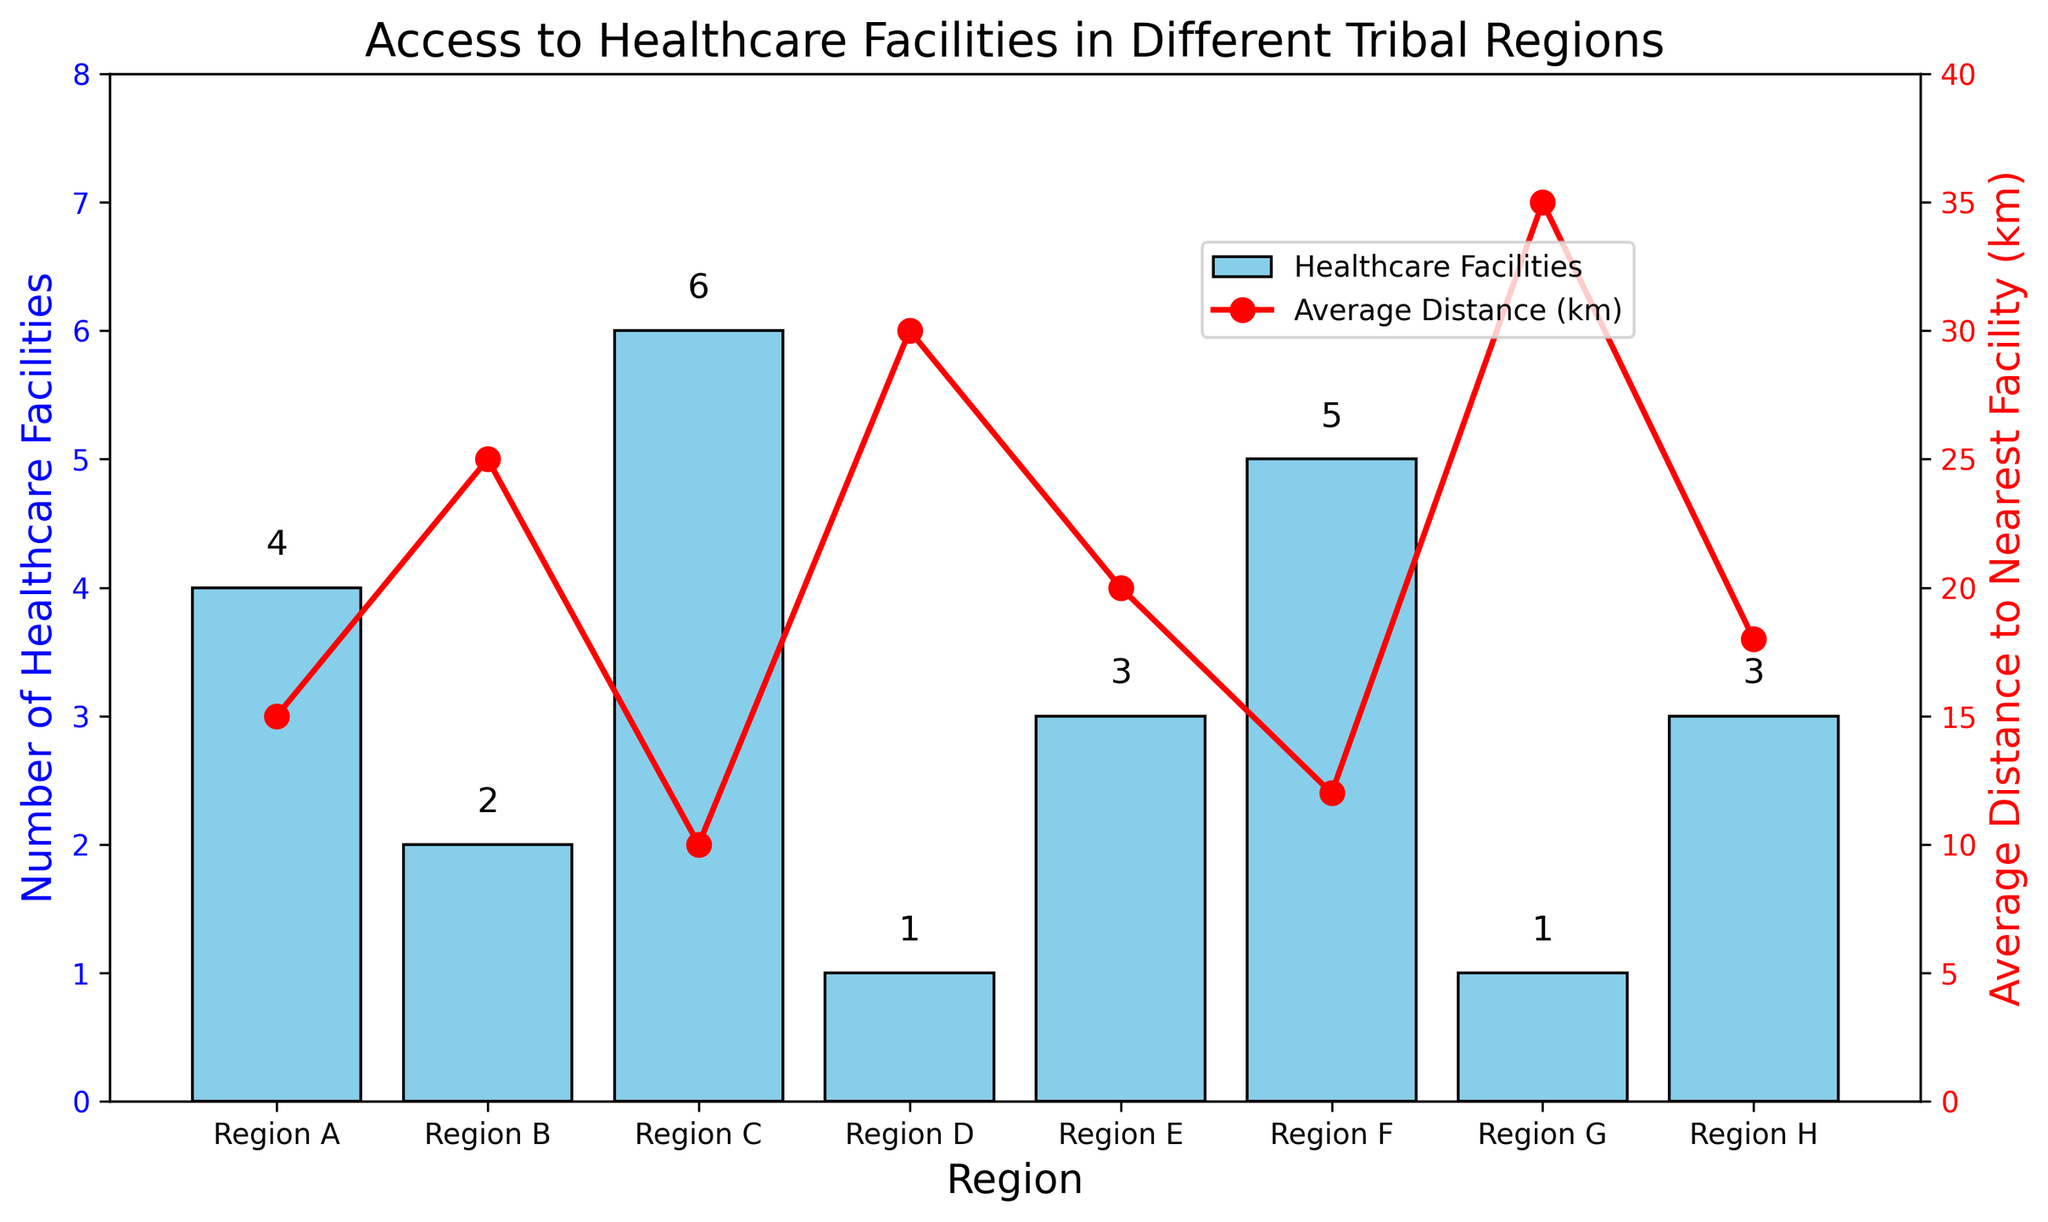What is the region with the highest number of healthcare facilities? Look at the height of the bars on the bar chart. The bar with the highest value corresponds to Region C, which shows 6 healthcare facilities.
Answer: Region C How many healthcare facilities are there in Region D? Find the bar corresponding to Region D and look at its height value. The height indicates there is 1 healthcare facility in Region D.
Answer: 1 Which region has the shortest average distance to the nearest healthcare facility? Look at the line plot and identify the point with the lowest value. This point is closest to the x-axis and corresponds to Region C, with a distance of 10 km.
Answer: Region C What is the difference in the average distance to the nearest facility between Region A and Region D? Subtract the average distance of Region A (15 km) from Region D (30 km). 30 - 15 = 15 km.
Answer: 15 km Which region has fewer than 3 healthcare facilities but a higher average distance to the nearest facility than Region E? Regions B, D, and G have fewer than 3 healthcare facilities. Comparing their average distances: Region B (25 km), Region D (30 km), Region G (35 km), and Region E's distance is 20 km. Only Regions B, D, and G have higher distances than Region E.
Answer: Regions B, D, G Which region has both exactly 3 healthcare facilities and an average distance to the nearest facility greater than 15 km? Regions E and H have exactly 3 healthcare facilities. Compare their average distances: Region E (20 km) and Region H (18 km). Both distances are greater than 15 km.
Answer: Regions E, H If the total number of healthcare facilities is summed across all regions, what is the total? Add the number of healthcare facilities in all regions: 4 (A) + 2 (B) + 6 (C) + 1 (D) + 3 (E) + 5 (F) + 1 (G) + 3 (H) = 25.
Answer: 25 By how much does the average distance to the nearest healthcare facility vary between Region F and Region G? Subtract the average distance of Region F (12 km) from Region G (35 km). 35 - 12 = 23 km.
Answer: 23 km Which region has the closest average distance to the nearest healthcare facility but only has 1 healthcare facility? Regions D and G have 1 healthcare facility. Compare their average distances: Region D (30 km) and Region G (35 km). The closest distance is 30 km in Region D.
Answer: Region D What is the average number of healthcare facilities across all regions? Sum the number of facilities (25, calculated earlier) and divide by the number of regions (8). 25/8 = 3.125.
Answer: 3.125 